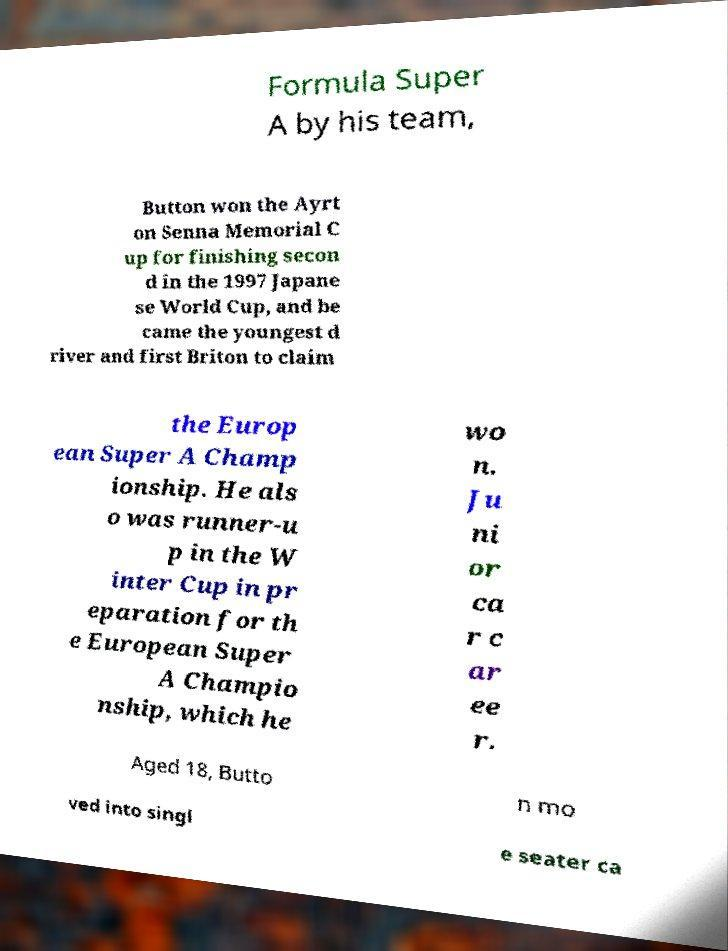There's text embedded in this image that I need extracted. Can you transcribe it verbatim? Formula Super A by his team, Button won the Ayrt on Senna Memorial C up for finishing secon d in the 1997 Japane se World Cup, and be came the youngest d river and first Briton to claim the Europ ean Super A Champ ionship. He als o was runner-u p in the W inter Cup in pr eparation for th e European Super A Champio nship, which he wo n. Ju ni or ca r c ar ee r. Aged 18, Butto n mo ved into singl e seater ca 